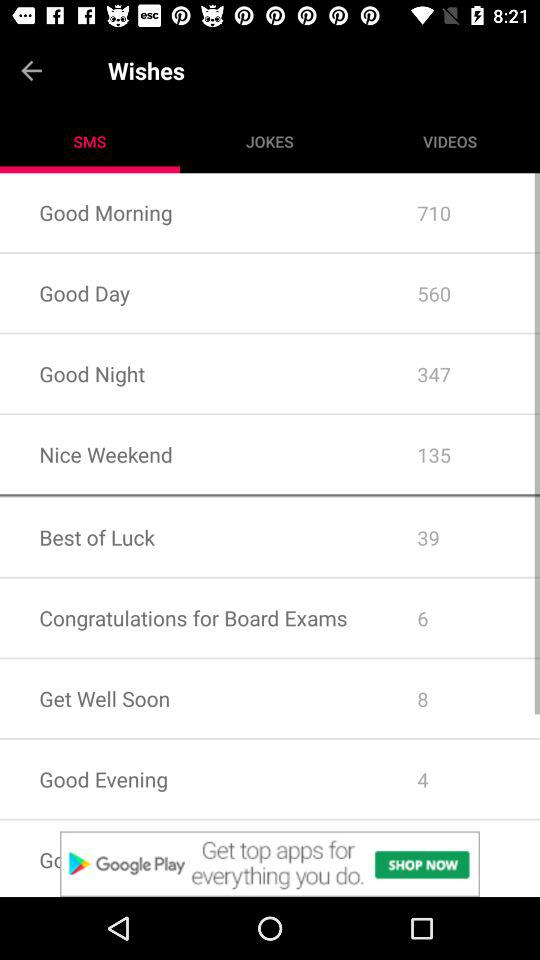Which tab is selected? The selected tab is "SMS". 